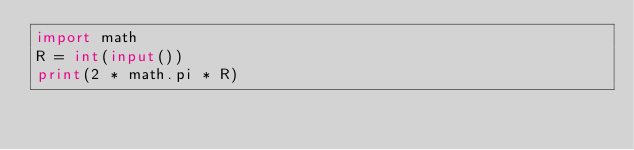Convert code to text. <code><loc_0><loc_0><loc_500><loc_500><_Python_>import math
R = int(input())
print(2 * math.pi * R)
</code> 